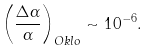Convert formula to latex. <formula><loc_0><loc_0><loc_500><loc_500>\left ( \frac { \Delta \alpha } { \alpha } \right ) _ { O k l o } \sim 1 0 ^ { - 6 } .</formula> 